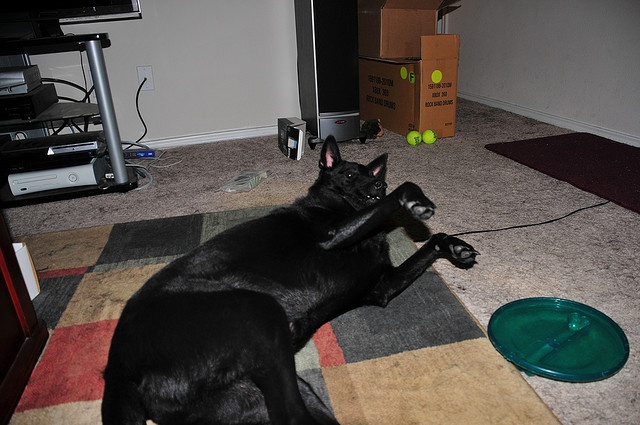Describe the objects in this image and their specific colors. I can see dog in black, gray, darkgray, and brown tones, frisbee in black, teal, and darkblue tones, tv in black and gray tones, sports ball in black, olive, khaki, and darkgreen tones, and sports ball in black, olive, and darkgreen tones in this image. 